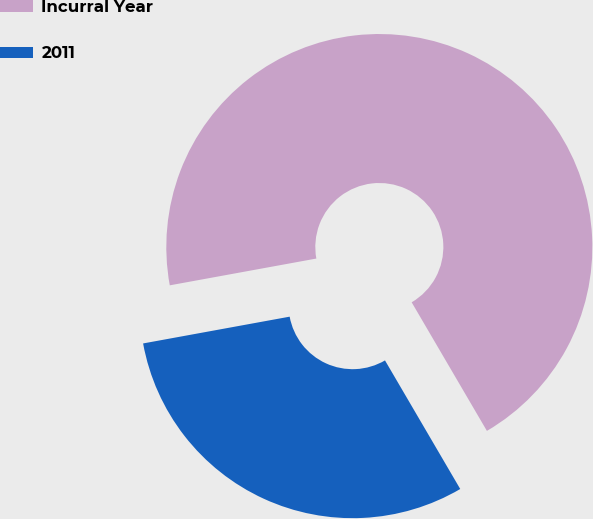<chart> <loc_0><loc_0><loc_500><loc_500><pie_chart><fcel>Incurral Year<fcel>2011<nl><fcel>69.45%<fcel>30.55%<nl></chart> 